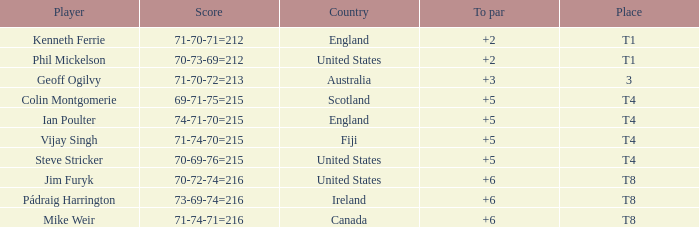Who was the competitor at the rank of t1 in to par with a score of 70-73-69=212? 2.0. 